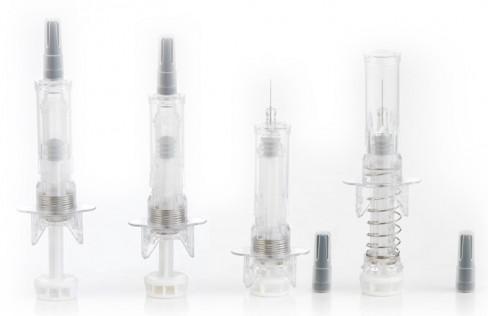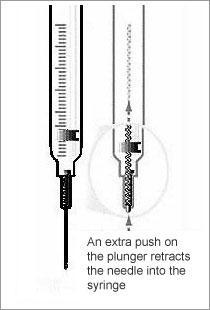The first image is the image on the left, the second image is the image on the right. Evaluate the accuracy of this statement regarding the images: "The image on the right has two syringes.". Is it true? Answer yes or no. Yes. 